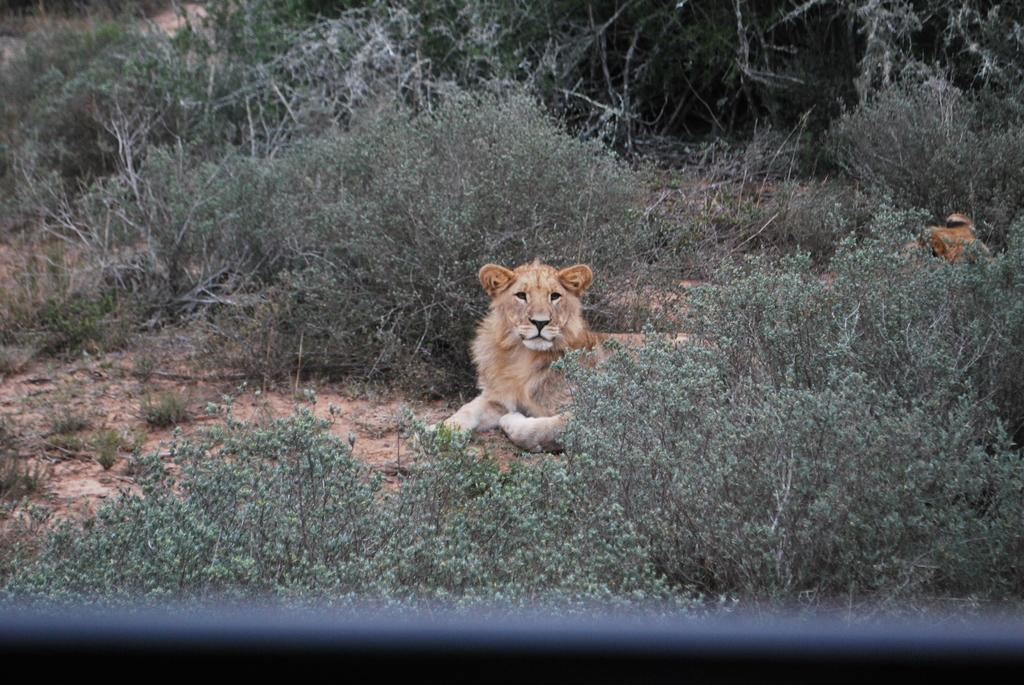What animal is the main subject of the image? There is a lion in the image. Where is the lion located in the image? The lion is on the ground. What other elements can be seen in the image besides the lion? There are plants in the image. What type of competition is the lion participating in during its journey in the image? There is no competition or journey depicted in the image; it simply shows a lion on the ground with plants nearby. Can you tell me how many geese are present in the image? There are no geese present in the image. 